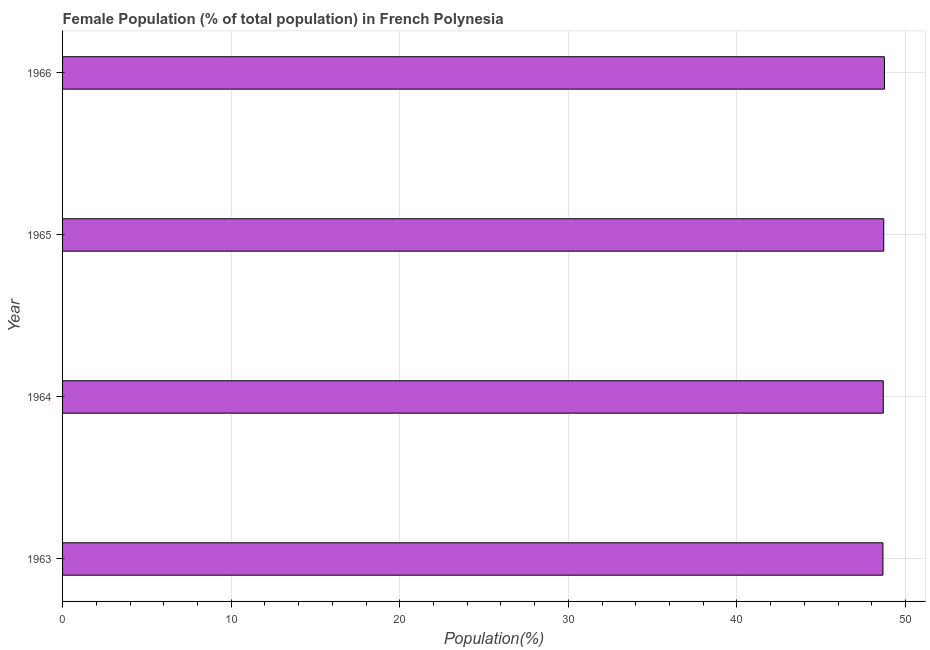Does the graph contain grids?
Keep it short and to the point. Yes. What is the title of the graph?
Ensure brevity in your answer.  Female Population (% of total population) in French Polynesia. What is the label or title of the X-axis?
Offer a very short reply. Population(%). What is the female population in 1964?
Ensure brevity in your answer.  48.68. Across all years, what is the maximum female population?
Offer a very short reply. 48.75. Across all years, what is the minimum female population?
Keep it short and to the point. 48.66. In which year was the female population maximum?
Provide a short and direct response. 1966. What is the sum of the female population?
Ensure brevity in your answer.  194.79. What is the difference between the female population in 1963 and 1964?
Offer a very short reply. -0.02. What is the average female population per year?
Your answer should be very brief. 48.7. What is the median female population?
Your answer should be compact. 48.69. In how many years, is the female population greater than 24 %?
Give a very brief answer. 4. Do a majority of the years between 1966 and 1963 (inclusive) have female population greater than 26 %?
Keep it short and to the point. Yes. What is the ratio of the female population in 1964 to that in 1966?
Give a very brief answer. 1. Is the female population in 1965 less than that in 1966?
Keep it short and to the point. Yes. Is the difference between the female population in 1964 and 1966 greater than the difference between any two years?
Make the answer very short. No. What is the difference between the highest and the lowest female population?
Offer a terse response. 0.09. In how many years, is the female population greater than the average female population taken over all years?
Provide a short and direct response. 2. Are all the bars in the graph horizontal?
Make the answer very short. Yes. Are the values on the major ticks of X-axis written in scientific E-notation?
Give a very brief answer. No. What is the Population(%) in 1963?
Your answer should be compact. 48.66. What is the Population(%) in 1964?
Your answer should be compact. 48.68. What is the Population(%) in 1965?
Your answer should be very brief. 48.71. What is the Population(%) of 1966?
Provide a short and direct response. 48.75. What is the difference between the Population(%) in 1963 and 1964?
Your answer should be compact. -0.02. What is the difference between the Population(%) in 1963 and 1965?
Your response must be concise. -0.05. What is the difference between the Population(%) in 1963 and 1966?
Keep it short and to the point. -0.09. What is the difference between the Population(%) in 1964 and 1965?
Your answer should be very brief. -0.03. What is the difference between the Population(%) in 1964 and 1966?
Your answer should be very brief. -0.07. What is the difference between the Population(%) in 1965 and 1966?
Your response must be concise. -0.04. What is the ratio of the Population(%) in 1964 to that in 1966?
Offer a terse response. 1. What is the ratio of the Population(%) in 1965 to that in 1966?
Offer a terse response. 1. 